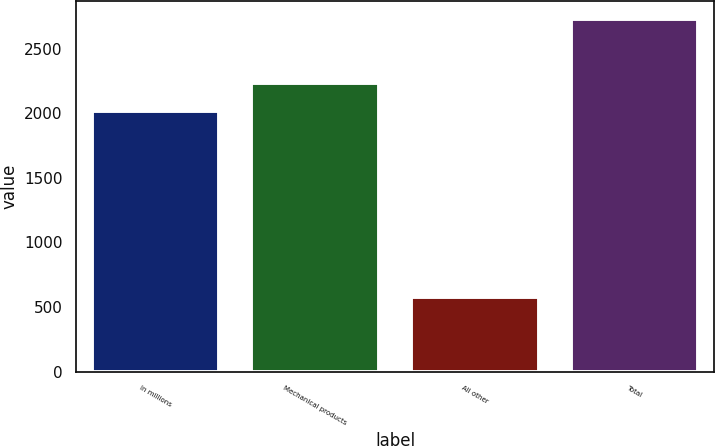Convert chart. <chart><loc_0><loc_0><loc_500><loc_500><bar_chart><fcel>In millions<fcel>Mechanical products<fcel>All other<fcel>Total<nl><fcel>2018<fcel>2233.52<fcel>576.5<fcel>2731.7<nl></chart> 